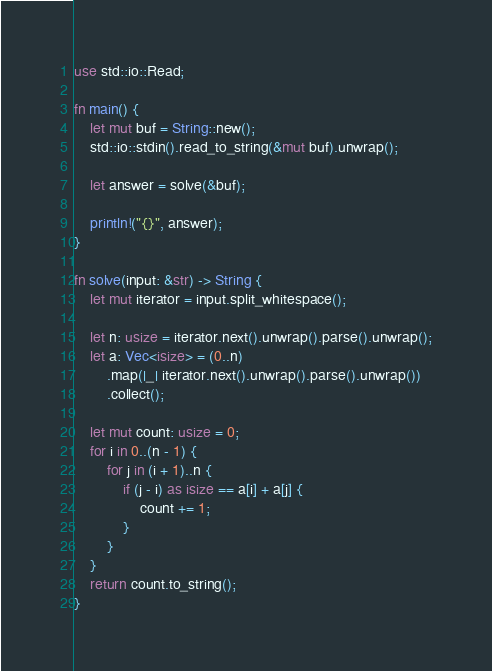Convert code to text. <code><loc_0><loc_0><loc_500><loc_500><_Rust_>use std::io::Read;

fn main() {
    let mut buf = String::new();
    std::io::stdin().read_to_string(&mut buf).unwrap();

    let answer = solve(&buf);

    println!("{}", answer);
}

fn solve(input: &str) -> String {
    let mut iterator = input.split_whitespace();

    let n: usize = iterator.next().unwrap().parse().unwrap();
    let a: Vec<isize> = (0..n)
        .map(|_| iterator.next().unwrap().parse().unwrap())
        .collect();

    let mut count: usize = 0;
    for i in 0..(n - 1) {
        for j in (i + 1)..n {
            if (j - i) as isize == a[i] + a[j] {
                count += 1;
            }
        }
    }
    return count.to_string();
}
</code> 